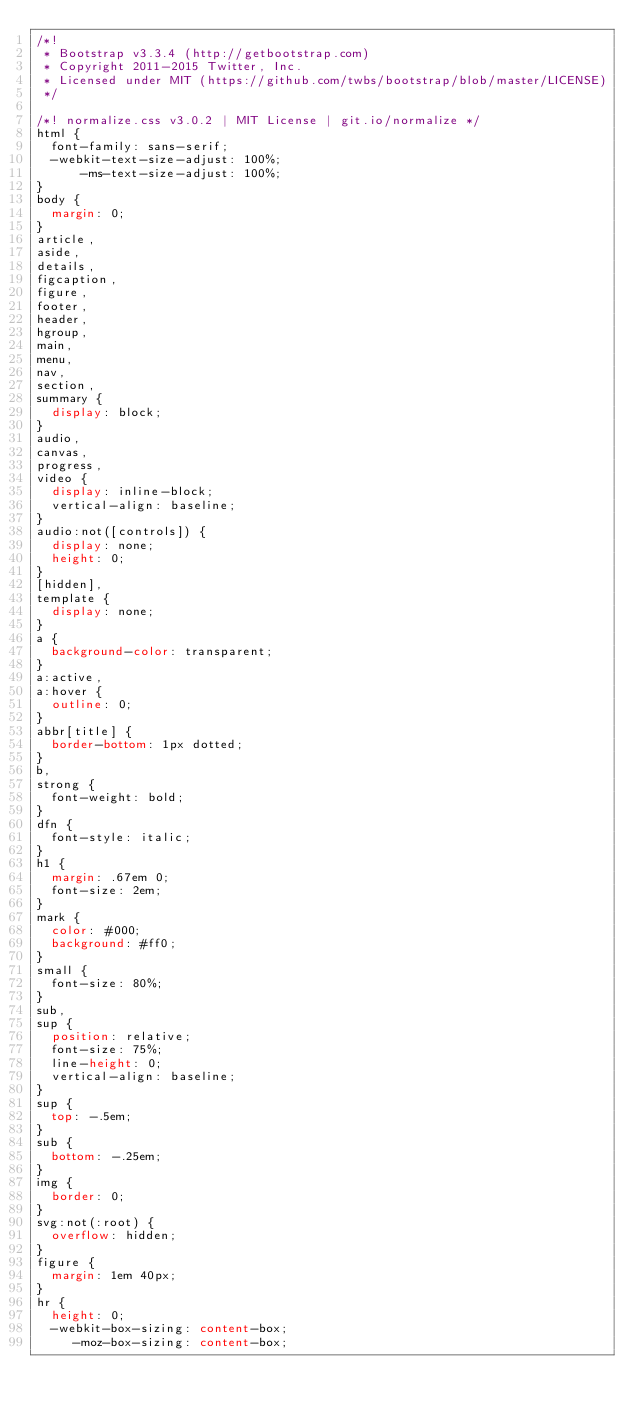<code> <loc_0><loc_0><loc_500><loc_500><_CSS_>/*!
 * Bootstrap v3.3.4 (http://getbootstrap.com)
 * Copyright 2011-2015 Twitter, Inc.
 * Licensed under MIT (https://github.com/twbs/bootstrap/blob/master/LICENSE)
 */

/*! normalize.css v3.0.2 | MIT License | git.io/normalize */
html {
  font-family: sans-serif;
  -webkit-text-size-adjust: 100%;
      -ms-text-size-adjust: 100%;
}
body {
  margin: 0;
}
article,
aside,
details,
figcaption,
figure,
footer,
header,
hgroup,
main,
menu,
nav,
section,
summary {
  display: block;
}
audio,
canvas,
progress,
video {
  display: inline-block;
  vertical-align: baseline;
}
audio:not([controls]) {
  display: none;
  height: 0;
}
[hidden],
template {
  display: none;
}
a {
  background-color: transparent;
}
a:active,
a:hover {
  outline: 0;
}
abbr[title] {
  border-bottom: 1px dotted;
}
b,
strong {
  font-weight: bold;
}
dfn {
  font-style: italic;
}
h1 {
  margin: .67em 0;
  font-size: 2em;
}
mark {
  color: #000;
  background: #ff0;
}
small {
  font-size: 80%;
}
sub,
sup {
  position: relative;
  font-size: 75%;
  line-height: 0;
  vertical-align: baseline;
}
sup {
  top: -.5em;
}
sub {
  bottom: -.25em;
}
img {
  border: 0;
}
svg:not(:root) {
  overflow: hidden;
}
figure {
  margin: 1em 40px;
}
hr {
  height: 0;
  -webkit-box-sizing: content-box;
     -moz-box-sizing: content-box;</code> 